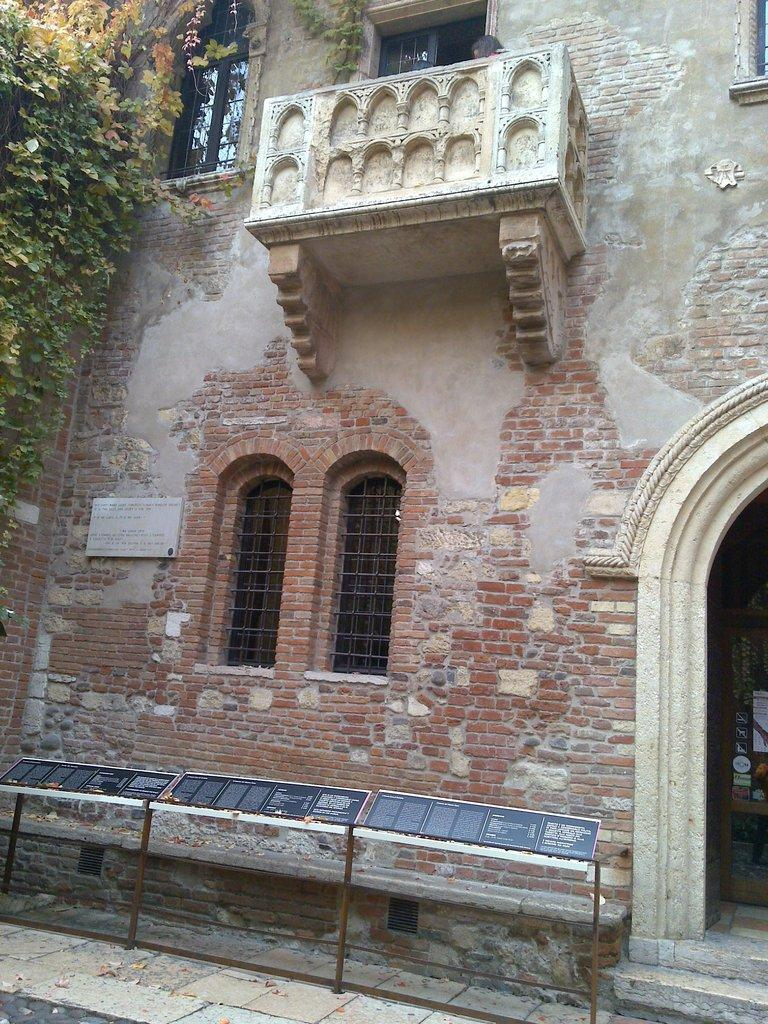What type of structure is present in the picture? There is a building in the picture. What can be seen on the left side of the picture? There are plants on the left side of the picture. What is written or displayed on the boards in the picture? There are boards with text in the picture. How many windows are visible in the picture? There are windows visible in the picture. Can you describe the human figure at the top of the picture? There appears to be a human figure at the top of the picture. What type of fish can be seen swimming near the human figure in the picture? There are no fish present in the picture; it features a building, plants, boards with text, windows, and a human figure. What is the chin of the giraffe like in the picture? There is no giraffe present in the picture, so its chin cannot be described. 